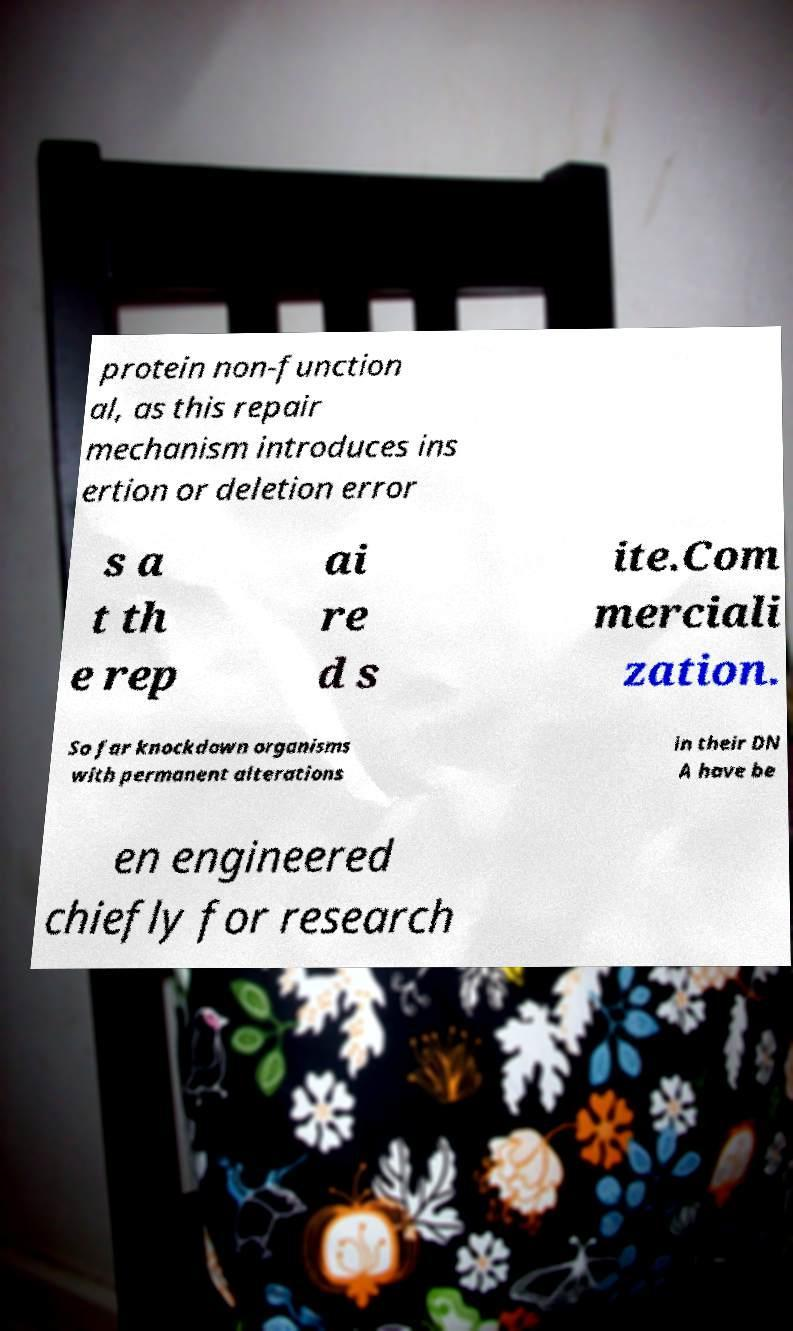What messages or text are displayed in this image? I need them in a readable, typed format. protein non-function al, as this repair mechanism introduces ins ertion or deletion error s a t th e rep ai re d s ite.Com merciali zation. So far knockdown organisms with permanent alterations in their DN A have be en engineered chiefly for research 